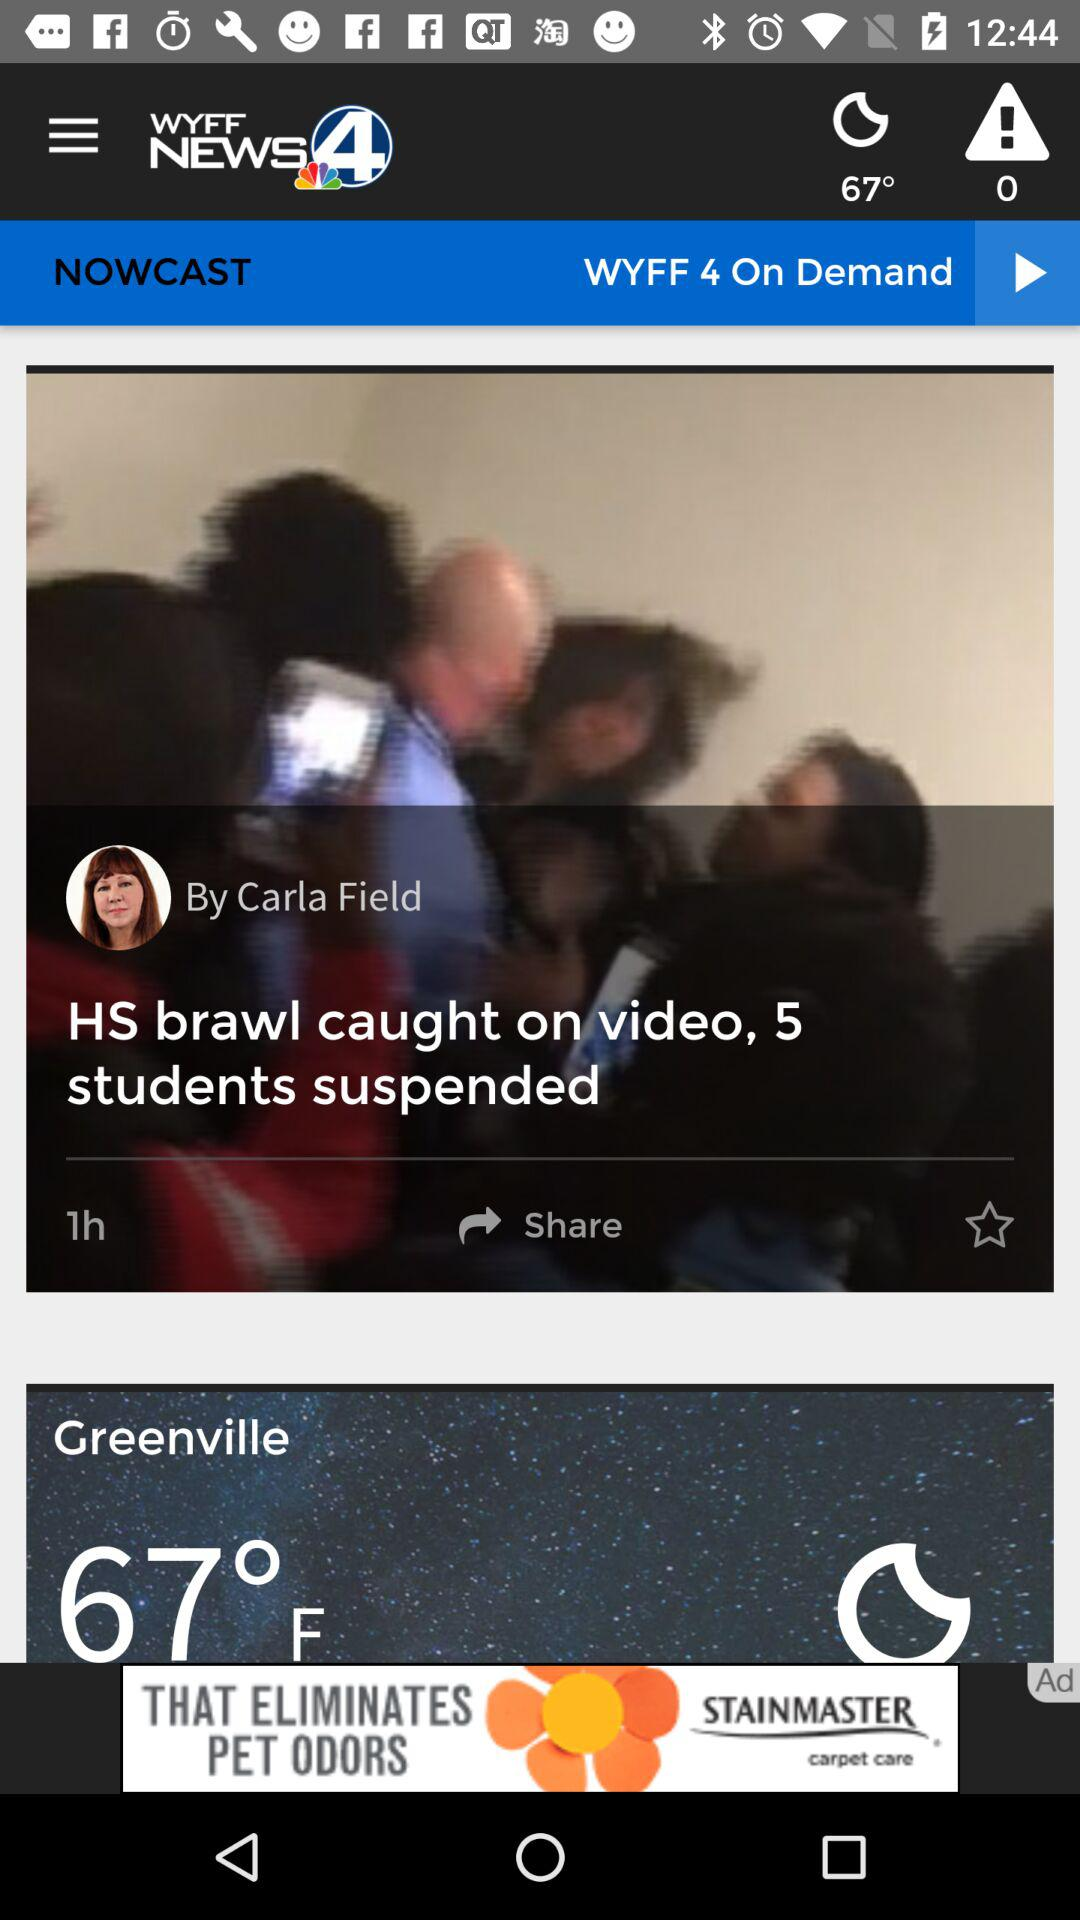On what date was "HS brawl caught on video, 5 students suspended" published?
When the provided information is insufficient, respond with <no answer>. <no answer> 